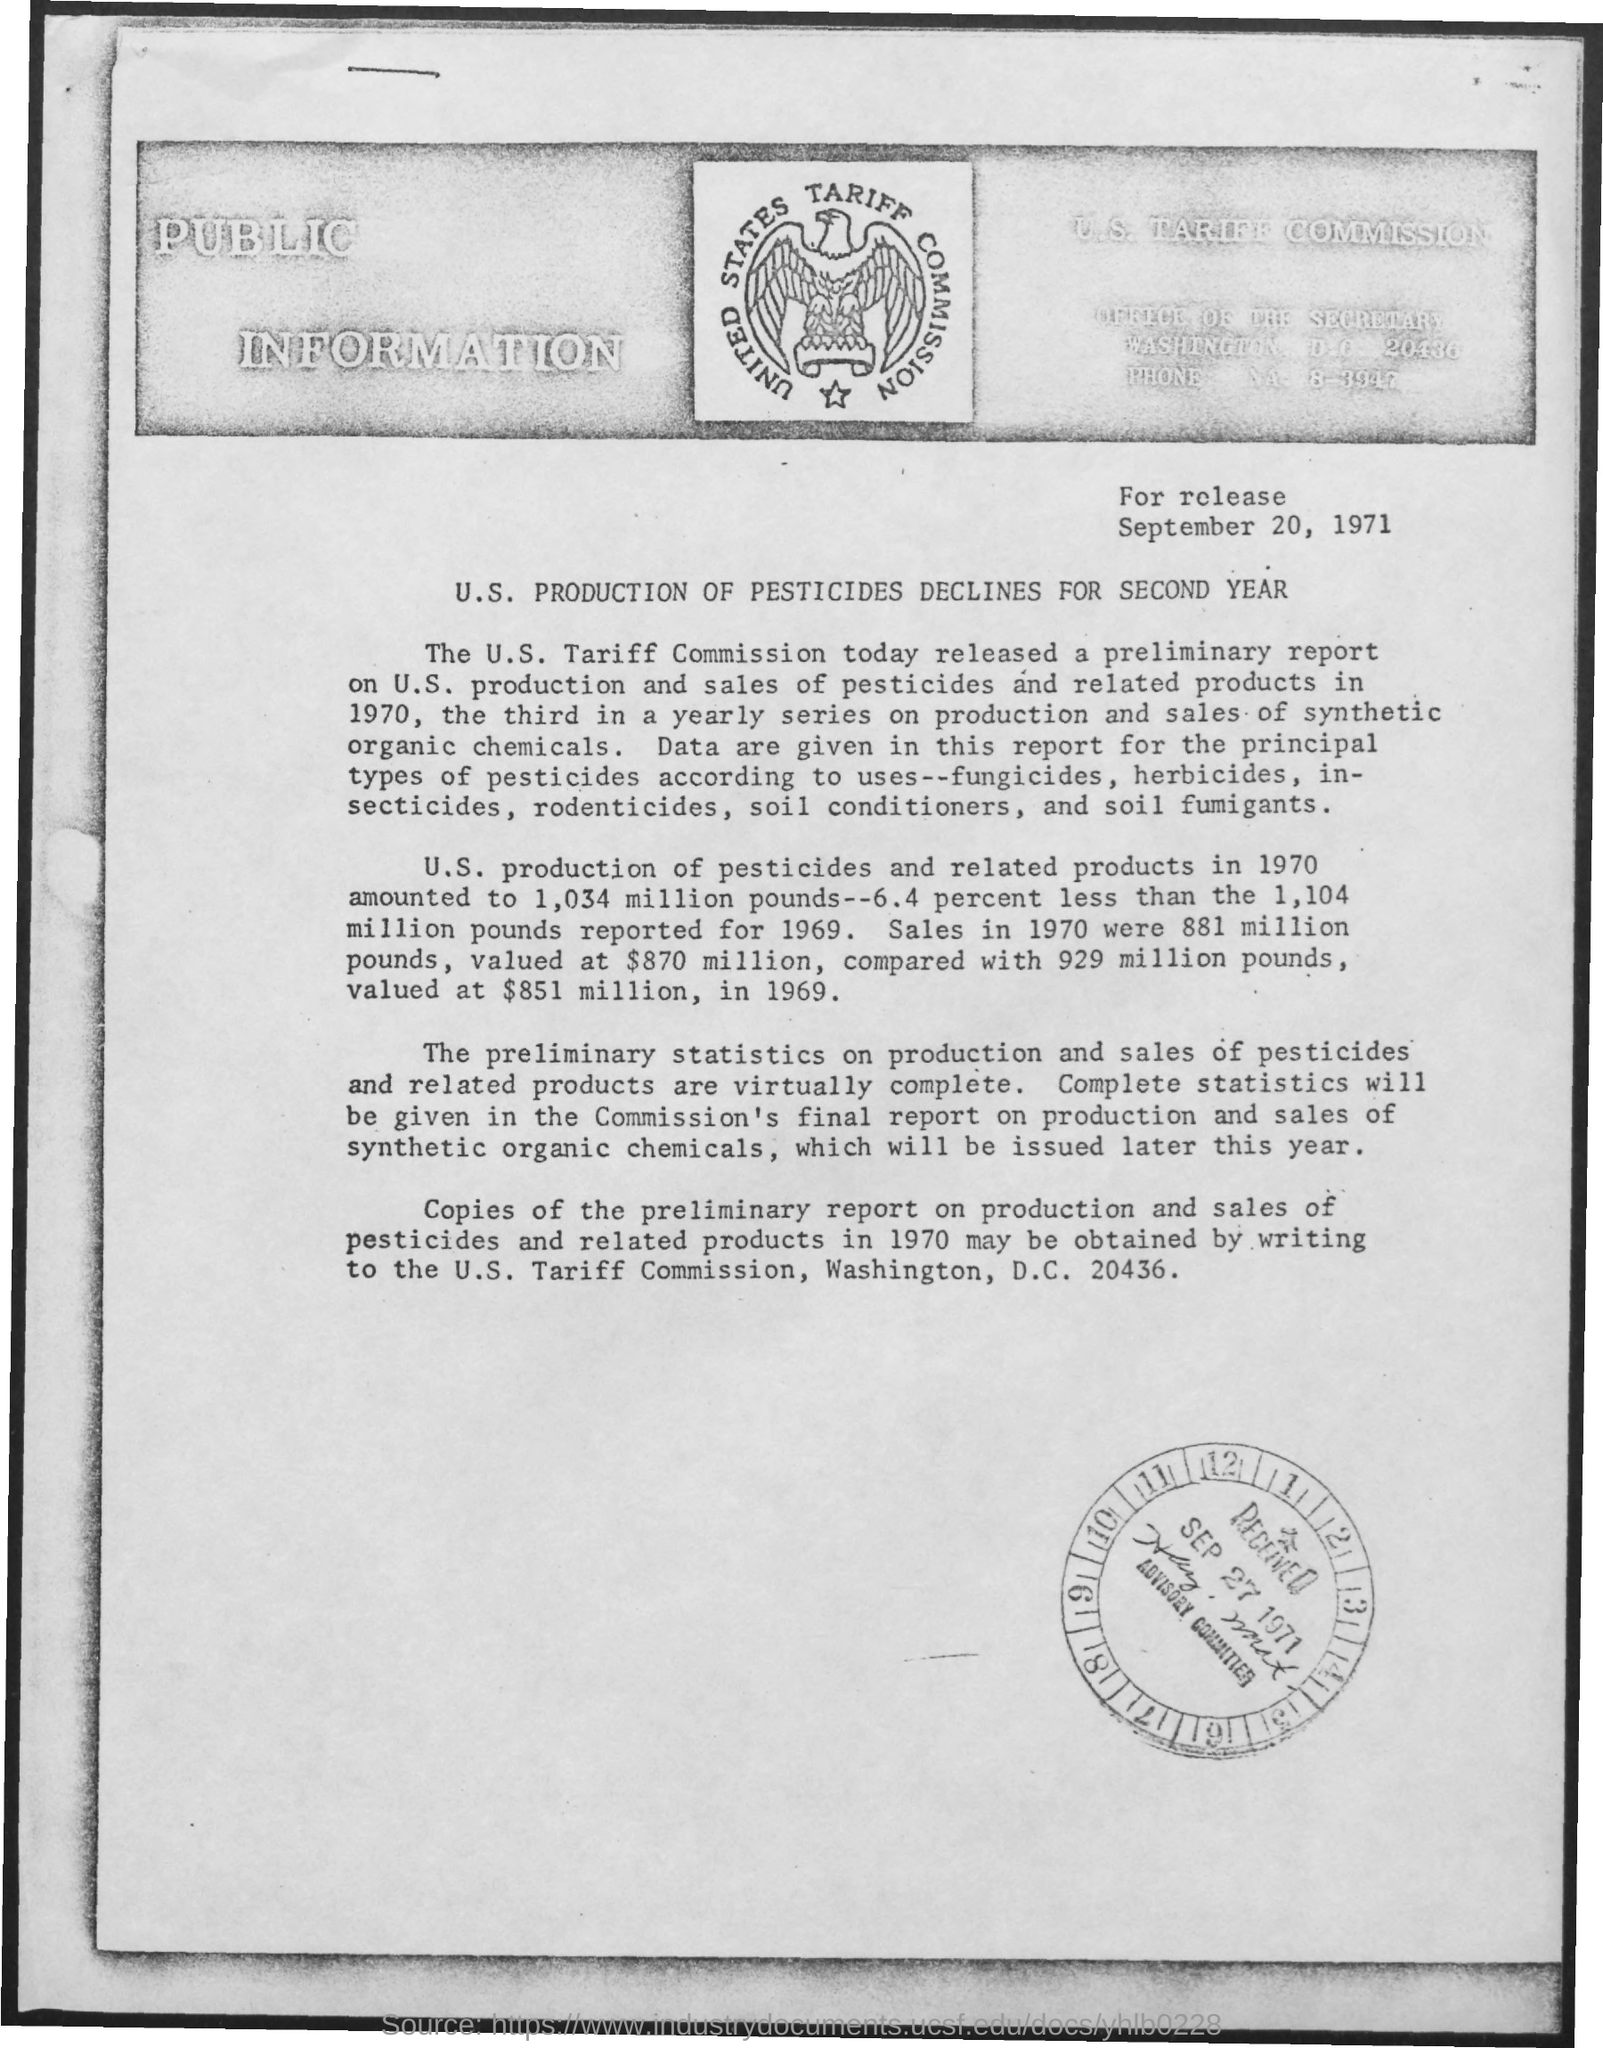Identify some key points in this picture. The date mentioned at the top of the page is September 20, 1971. The received date mentioned is September 27, 1971. 